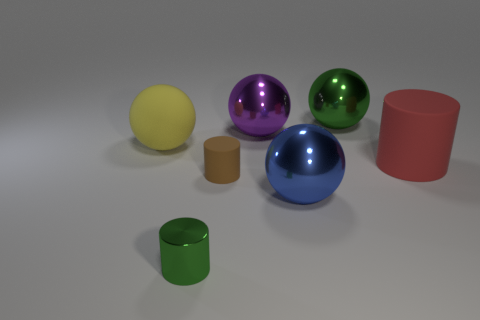There is a shiny thing that is the same color as the small metal cylinder; what is its size?
Offer a terse response. Large. What is the material of the large yellow thing that is the same shape as the blue shiny thing?
Offer a terse response. Rubber. There is a small cylinder that is on the right side of the small green cylinder; what number of shiny things are on the left side of it?
Ensure brevity in your answer.  1. Are there any other things that have the same color as the large cylinder?
Your answer should be very brief. No. There is another green object that is made of the same material as the tiny green object; what shape is it?
Ensure brevity in your answer.  Sphere. Do the tiny matte cylinder and the big cylinder have the same color?
Give a very brief answer. No. Is the object on the right side of the big green metallic object made of the same material as the green thing behind the yellow sphere?
Your answer should be compact. No. How many objects are red matte objects or big things in front of the purple metallic thing?
Ensure brevity in your answer.  3. Is there any other thing that is the same material as the large yellow sphere?
Your response must be concise. Yes. There is a large thing that is the same color as the metal cylinder; what shape is it?
Your answer should be compact. Sphere. 